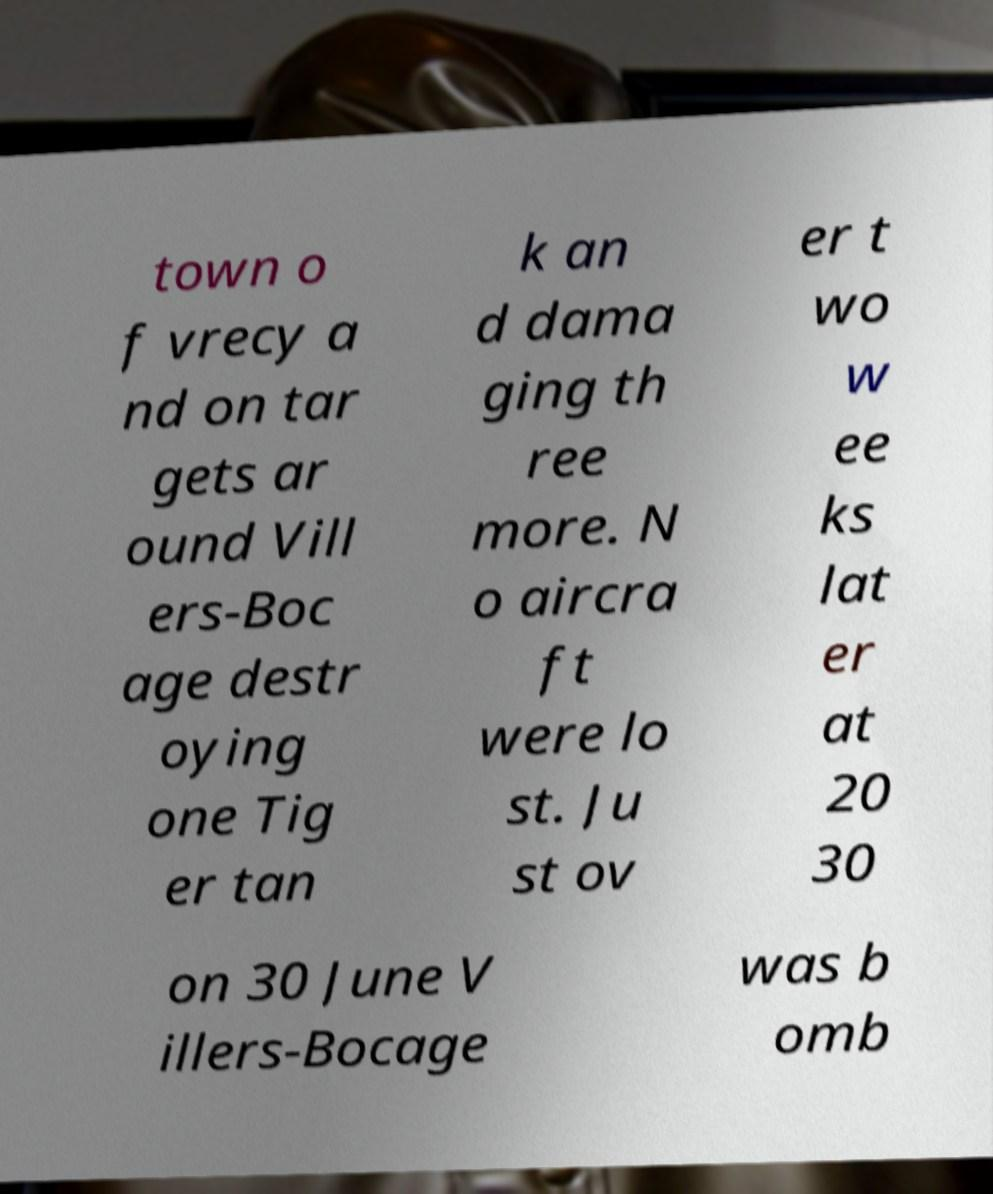I need the written content from this picture converted into text. Can you do that? town o f vrecy a nd on tar gets ar ound Vill ers-Boc age destr oying one Tig er tan k an d dama ging th ree more. N o aircra ft were lo st. Ju st ov er t wo w ee ks lat er at 20 30 on 30 June V illers-Bocage was b omb 